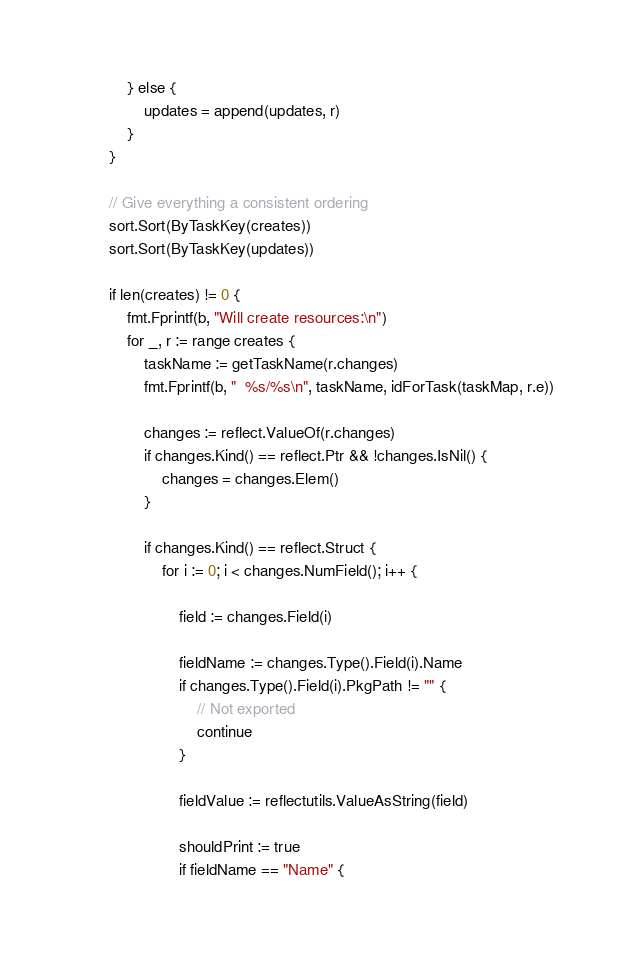Convert code to text. <code><loc_0><loc_0><loc_500><loc_500><_Go_>			} else {
				updates = append(updates, r)
			}
		}

		// Give everything a consistent ordering
		sort.Sort(ByTaskKey(creates))
		sort.Sort(ByTaskKey(updates))

		if len(creates) != 0 {
			fmt.Fprintf(b, "Will create resources:\n")
			for _, r := range creates {
				taskName := getTaskName(r.changes)
				fmt.Fprintf(b, "  %s/%s\n", taskName, idForTask(taskMap, r.e))

				changes := reflect.ValueOf(r.changes)
				if changes.Kind() == reflect.Ptr && !changes.IsNil() {
					changes = changes.Elem()
				}

				if changes.Kind() == reflect.Struct {
					for i := 0; i < changes.NumField(); i++ {

						field := changes.Field(i)

						fieldName := changes.Type().Field(i).Name
						if changes.Type().Field(i).PkgPath != "" {
							// Not exported
							continue
						}

						fieldValue := reflectutils.ValueAsString(field)

						shouldPrint := true
						if fieldName == "Name" {</code> 